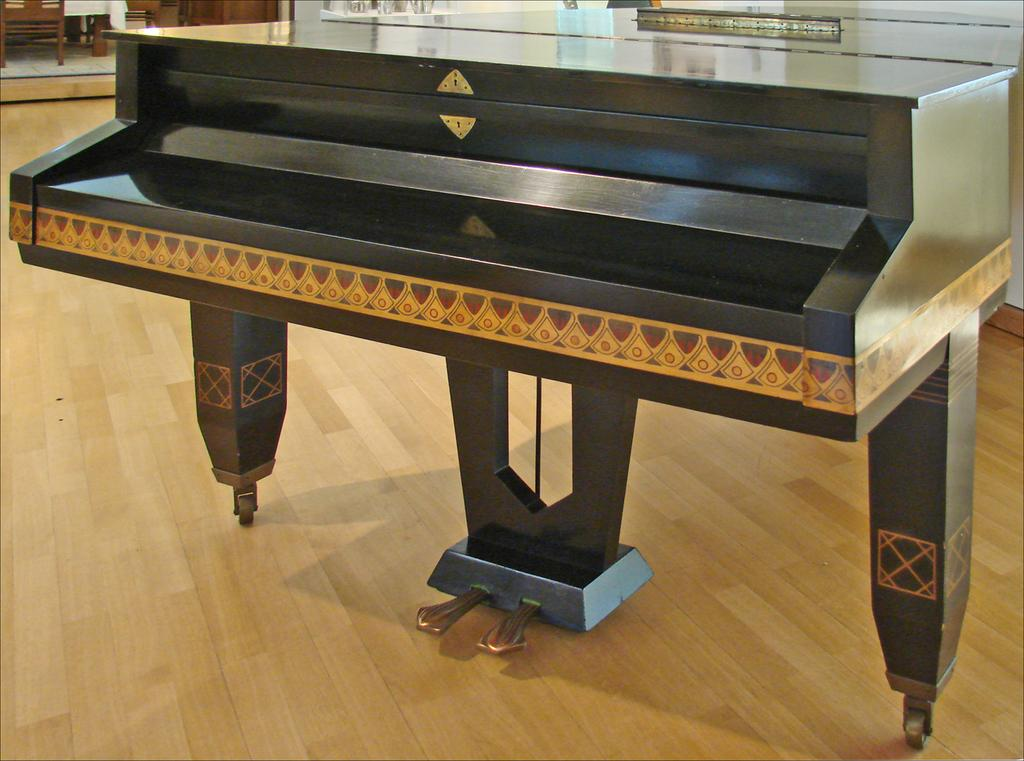What is the main object in the center of the image? There is a piano in the center of the image. How is the piano positioned in the image? The piano is on the ground. What can be seen in the background of the image? There are chairs and a wall visible in the background of the image. What type of orange tree can be seen growing in the wilderness behind the piano? There is no orange tree or wilderness present in the image; it features a piano on the ground with chairs and a wall in the background. 